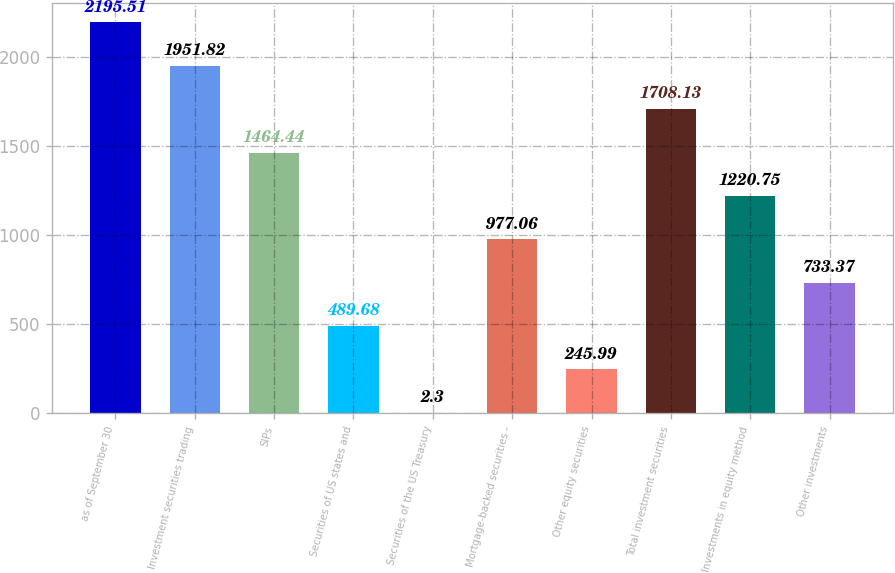<chart> <loc_0><loc_0><loc_500><loc_500><bar_chart><fcel>as of September 30<fcel>Investment securities trading<fcel>SIPs<fcel>Securities of US states and<fcel>Securities of the US Treasury<fcel>Mortgage-backed securities -<fcel>Other equity securities<fcel>Total investment securities<fcel>Investments in equity method<fcel>Other investments<nl><fcel>2195.51<fcel>1951.82<fcel>1464.44<fcel>489.68<fcel>2.3<fcel>977.06<fcel>245.99<fcel>1708.13<fcel>1220.75<fcel>733.37<nl></chart> 